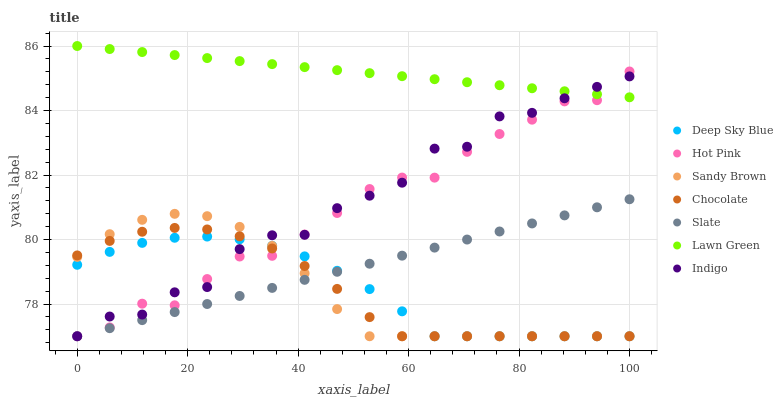Does Chocolate have the minimum area under the curve?
Answer yes or no. Yes. Does Lawn Green have the maximum area under the curve?
Answer yes or no. Yes. Does Indigo have the minimum area under the curve?
Answer yes or no. No. Does Indigo have the maximum area under the curve?
Answer yes or no. No. Is Lawn Green the smoothest?
Answer yes or no. Yes. Is Indigo the roughest?
Answer yes or no. Yes. Is Slate the smoothest?
Answer yes or no. No. Is Slate the roughest?
Answer yes or no. No. Does Indigo have the lowest value?
Answer yes or no. Yes. Does Lawn Green have the highest value?
Answer yes or no. Yes. Does Indigo have the highest value?
Answer yes or no. No. Is Deep Sky Blue less than Lawn Green?
Answer yes or no. Yes. Is Lawn Green greater than Slate?
Answer yes or no. Yes. Does Chocolate intersect Indigo?
Answer yes or no. Yes. Is Chocolate less than Indigo?
Answer yes or no. No. Is Chocolate greater than Indigo?
Answer yes or no. No. Does Deep Sky Blue intersect Lawn Green?
Answer yes or no. No. 